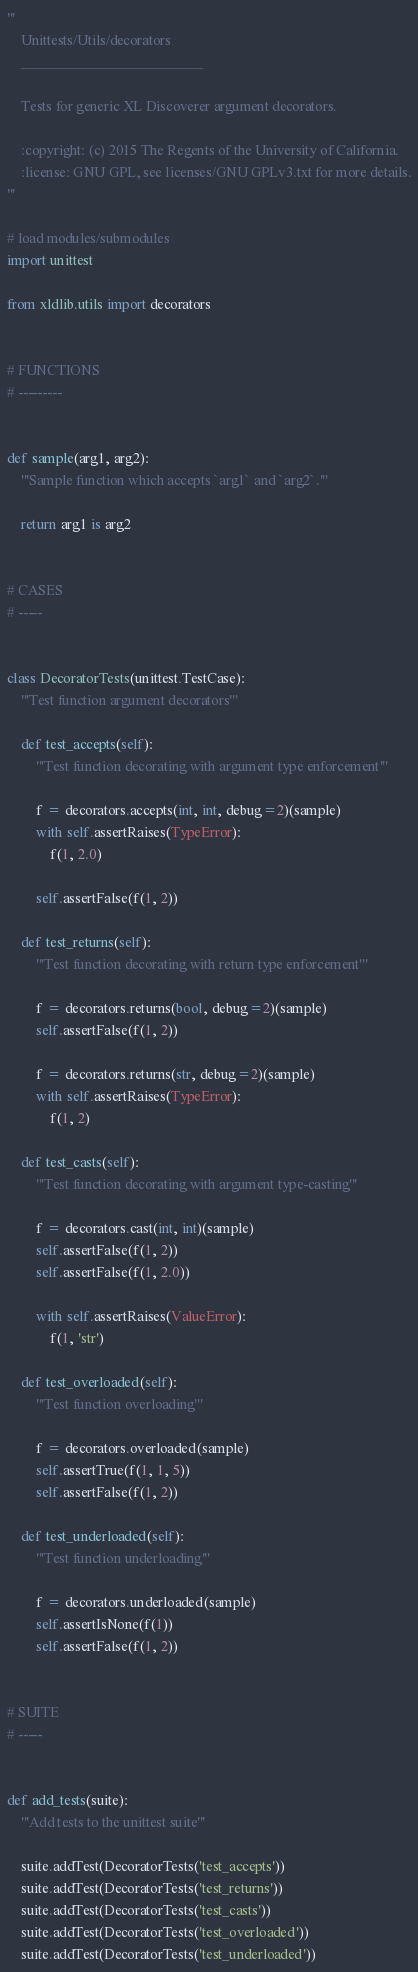Convert code to text. <code><loc_0><loc_0><loc_500><loc_500><_Python_>'''
    Unittests/Utils/decorators
    __________________________

    Tests for generic XL Discoverer argument decorators.

    :copyright: (c) 2015 The Regents of the University of California.
    :license: GNU GPL, see licenses/GNU GPLv3.txt for more details.
'''

# load modules/submodules
import unittest

from xldlib.utils import decorators


# FUNCTIONS
# ---------


def sample(arg1, arg2):
    '''Sample function which accepts `arg1` and `arg2`.'''

    return arg1 is arg2


# CASES
# -----


class DecoratorTests(unittest.TestCase):
    '''Test function argument decorators'''

    def test_accepts(self):
        '''Test function decorating with argument type enforcement'''

        f = decorators.accepts(int, int, debug=2)(sample)
        with self.assertRaises(TypeError):
            f(1, 2.0)

        self.assertFalse(f(1, 2))

    def test_returns(self):
        '''Test function decorating with return type enforcement'''

        f = decorators.returns(bool, debug=2)(sample)
        self.assertFalse(f(1, 2))

        f = decorators.returns(str, debug=2)(sample)
        with self.assertRaises(TypeError):
            f(1, 2)

    def test_casts(self):
        '''Test function decorating with argument type-casting'''

        f = decorators.cast(int, int)(sample)
        self.assertFalse(f(1, 2))
        self.assertFalse(f(1, 2.0))

        with self.assertRaises(ValueError):
            f(1, 'str')

    def test_overloaded(self):
        '''Test function overloading'''

        f = decorators.overloaded(sample)
        self.assertTrue(f(1, 1, 5))
        self.assertFalse(f(1, 2))

    def test_underloaded(self):
        '''Test function underloading'''

        f = decorators.underloaded(sample)
        self.assertIsNone(f(1))
        self.assertFalse(f(1, 2))


# SUITE
# -----


def add_tests(suite):
    '''Add tests to the unittest suite'''

    suite.addTest(DecoratorTests('test_accepts'))
    suite.addTest(DecoratorTests('test_returns'))
    suite.addTest(DecoratorTests('test_casts'))
    suite.addTest(DecoratorTests('test_overloaded'))
    suite.addTest(DecoratorTests('test_underloaded'))
</code> 